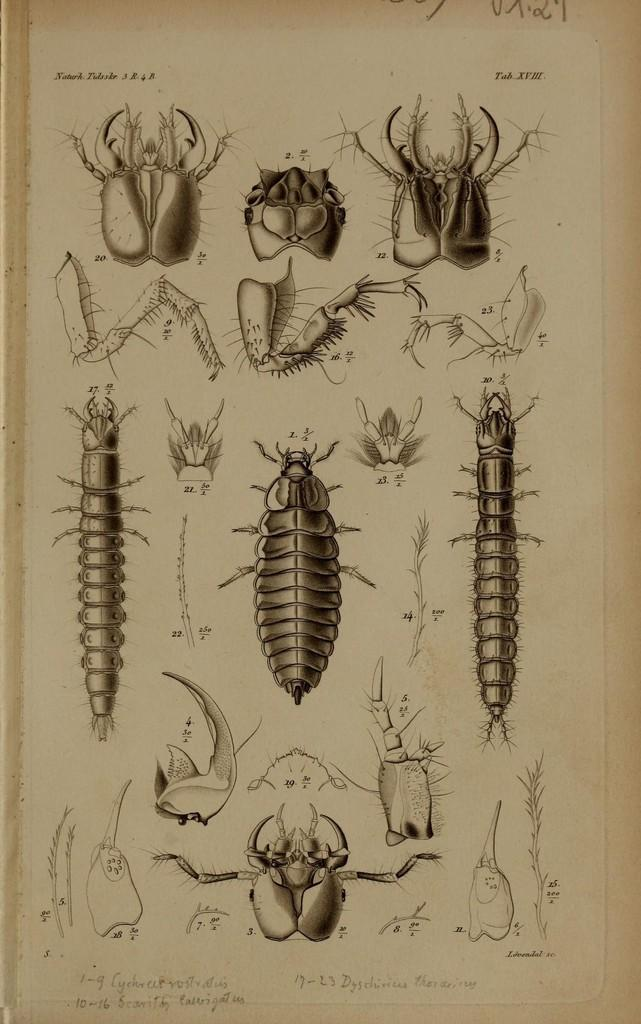What is present in the image related to a study or documentation? There is a paper in the image. What is depicted on the paper? The paper contains diagrams of different insects. Is there any text accompanying the diagrams? Yes, there is text on the paper. How does the paper affect the digestion of the insects depicted on it? The paper does not have any effect on the digestion of the insects; it is a static representation of their diagrams. 